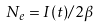Convert formula to latex. <formula><loc_0><loc_0><loc_500><loc_500>N _ { e } = I ( t ) / 2 \beta</formula> 